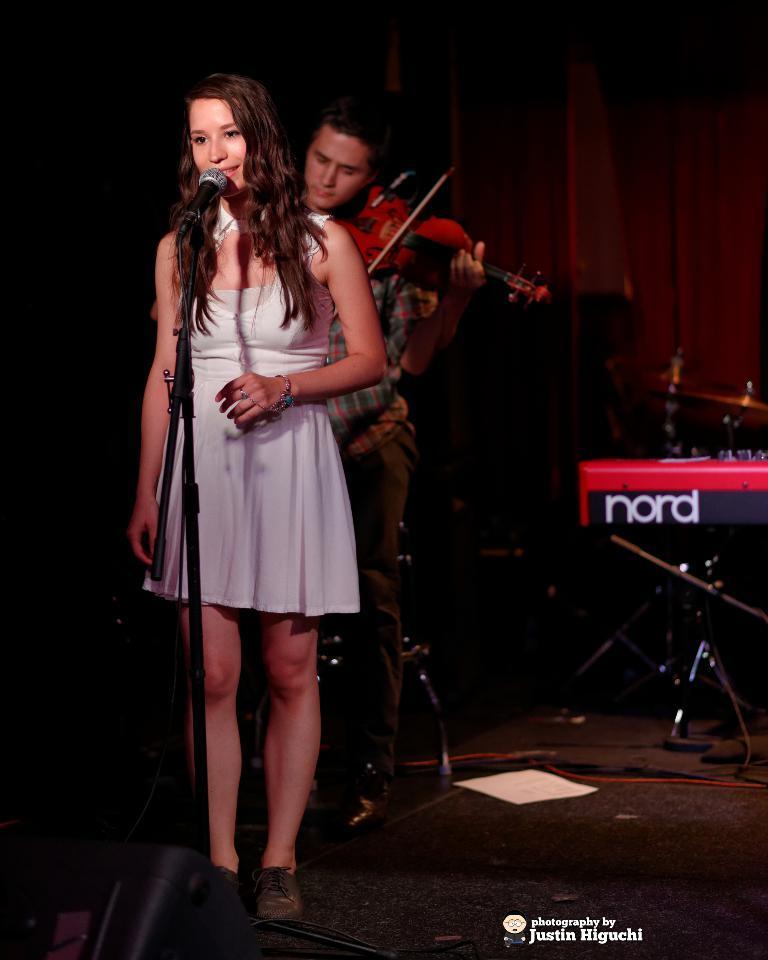In one or two sentences, can you explain what this image depicts? In this picture I can see a girl who is standing and in front of her I see a mic on the tripod and I see the watermark on the bottom of the image. In the background I see who is holding a violin in hands and on the right I see few musical instruments. 